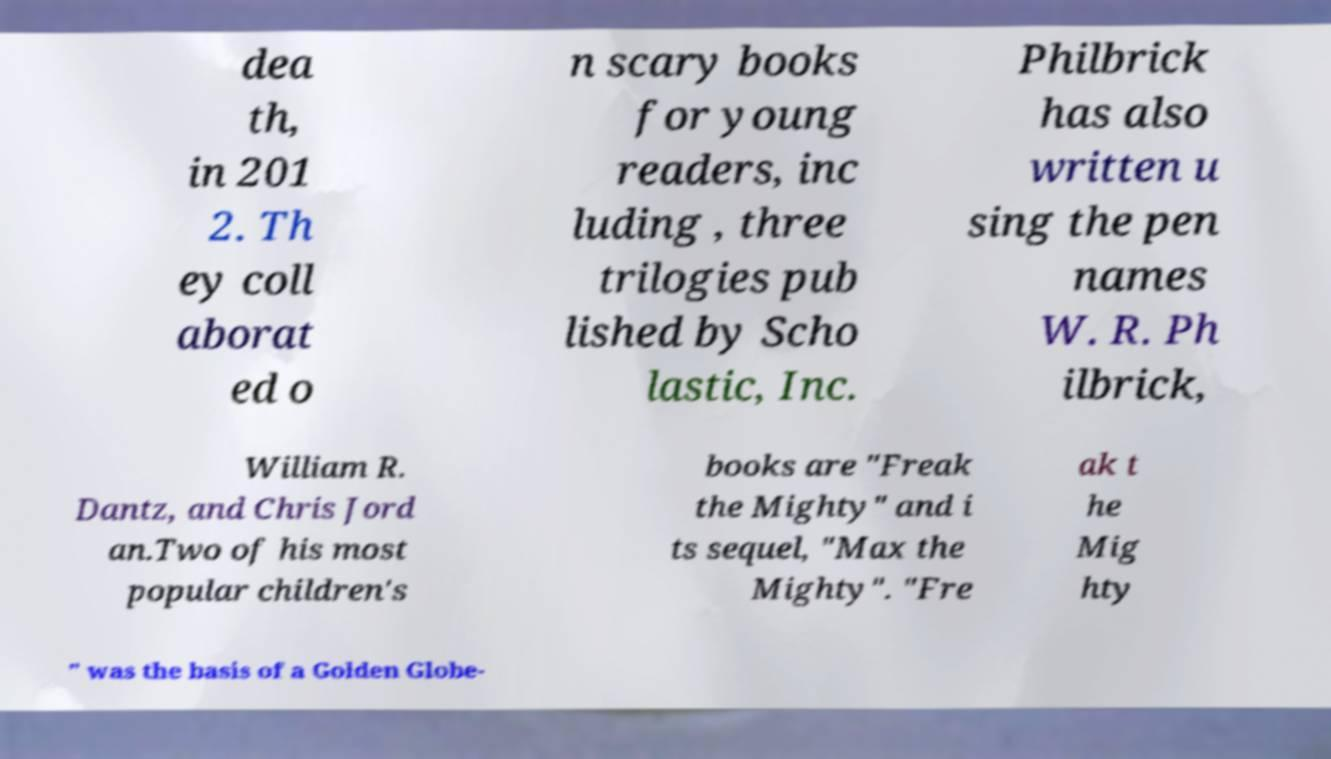I need the written content from this picture converted into text. Can you do that? dea th, in 201 2. Th ey coll aborat ed o n scary books for young readers, inc luding , three trilogies pub lished by Scho lastic, Inc. Philbrick has also written u sing the pen names W. R. Ph ilbrick, William R. Dantz, and Chris Jord an.Two of his most popular children's books are "Freak the Mighty" and i ts sequel, "Max the Mighty". "Fre ak t he Mig hty " was the basis of a Golden Globe- 